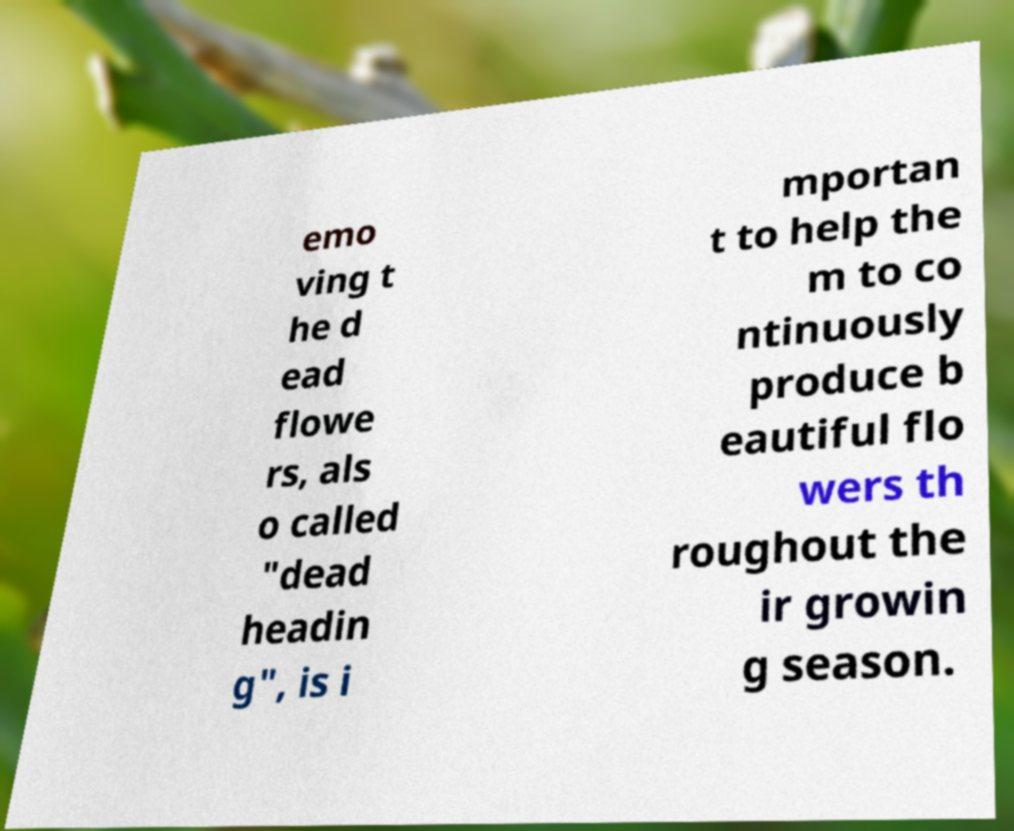Please identify and transcribe the text found in this image. emo ving t he d ead flowe rs, als o called "dead headin g", is i mportan t to help the m to co ntinuously produce b eautiful flo wers th roughout the ir growin g season. 